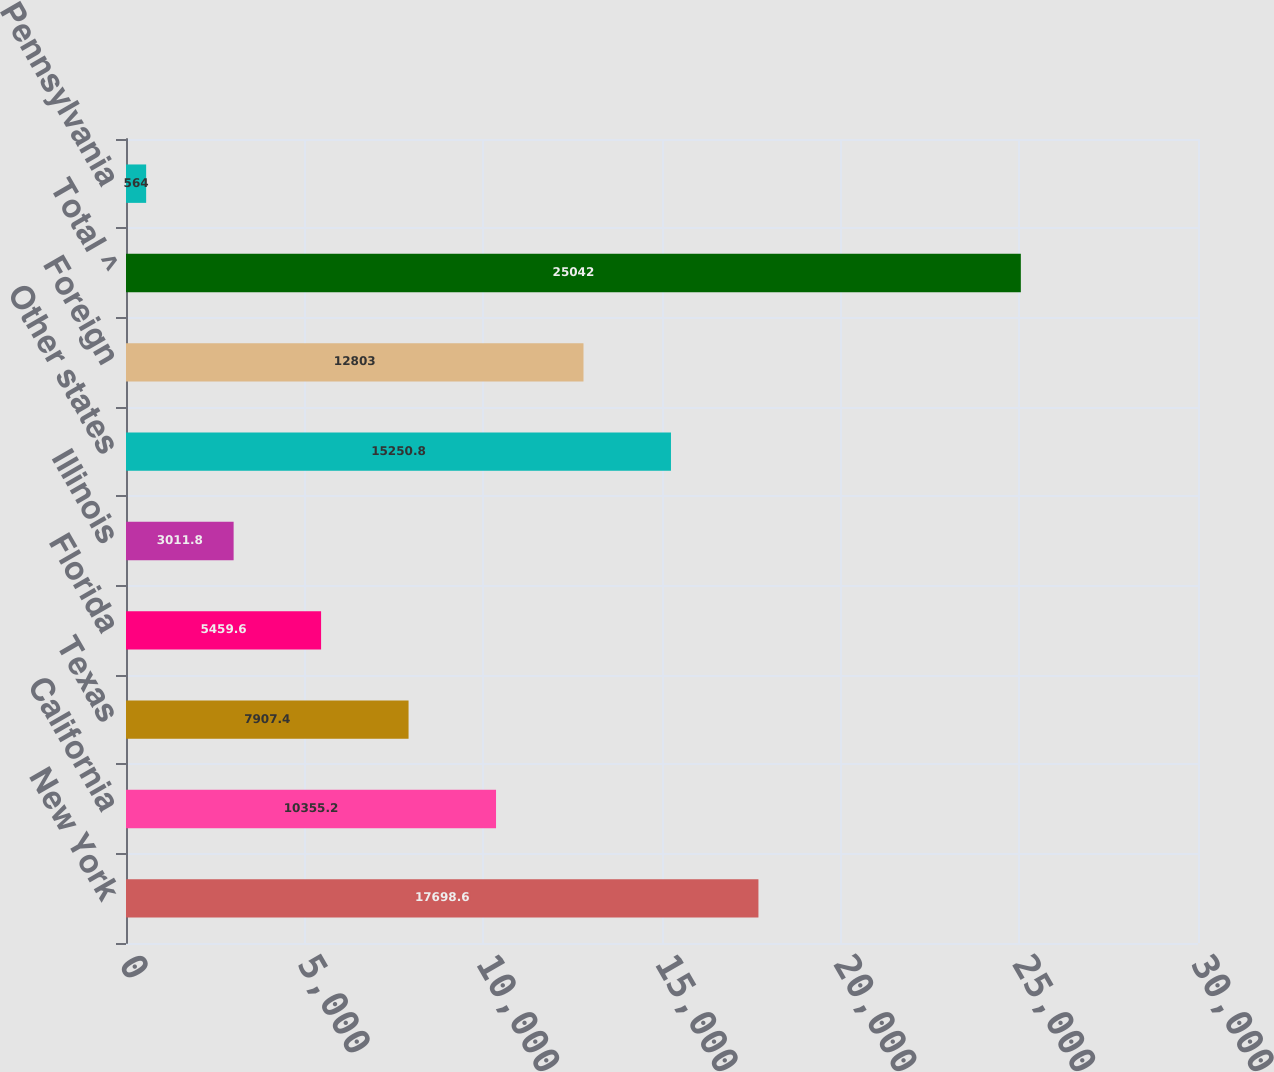<chart> <loc_0><loc_0><loc_500><loc_500><bar_chart><fcel>New York<fcel>California<fcel>Texas<fcel>Florida<fcel>Illinois<fcel>Other states<fcel>Foreign<fcel>Total ^<fcel>Pennsylvania<nl><fcel>17698.6<fcel>10355.2<fcel>7907.4<fcel>5459.6<fcel>3011.8<fcel>15250.8<fcel>12803<fcel>25042<fcel>564<nl></chart> 